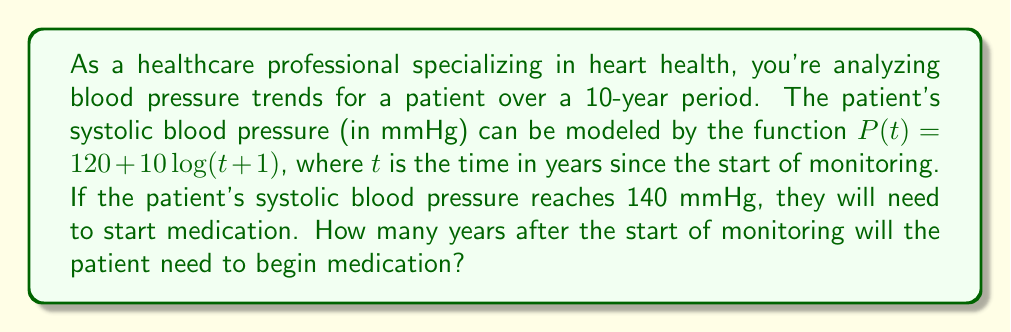Could you help me with this problem? To solve this problem, we need to find the value of $t$ when $P(t) = 140$. Let's approach this step-by-step:

1) We start with the equation: $P(t) = 120 + 10 \log(t+1)$

2) We want to find $t$ when $P(t) = 140$, so we set up the equation:
   $140 = 120 + 10 \log(t+1)$

3) Subtract 120 from both sides:
   $20 = 10 \log(t+1)$

4) Divide both sides by 10:
   $2 = \log(t+1)$

5) To solve for $t$, we need to apply the inverse function of $\log$, which is the exponential function:
   $e^2 = t+1$

6) Subtract 1 from both sides:
   $e^2 - 1 = t$

7) Calculate the value:
   $t \approx 6.389$

Therefore, the patient will need to start medication approximately 6.389 years after the start of monitoring.
Answer: $6.389$ years 